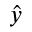<formula> <loc_0><loc_0><loc_500><loc_500>\hat { y }</formula> 